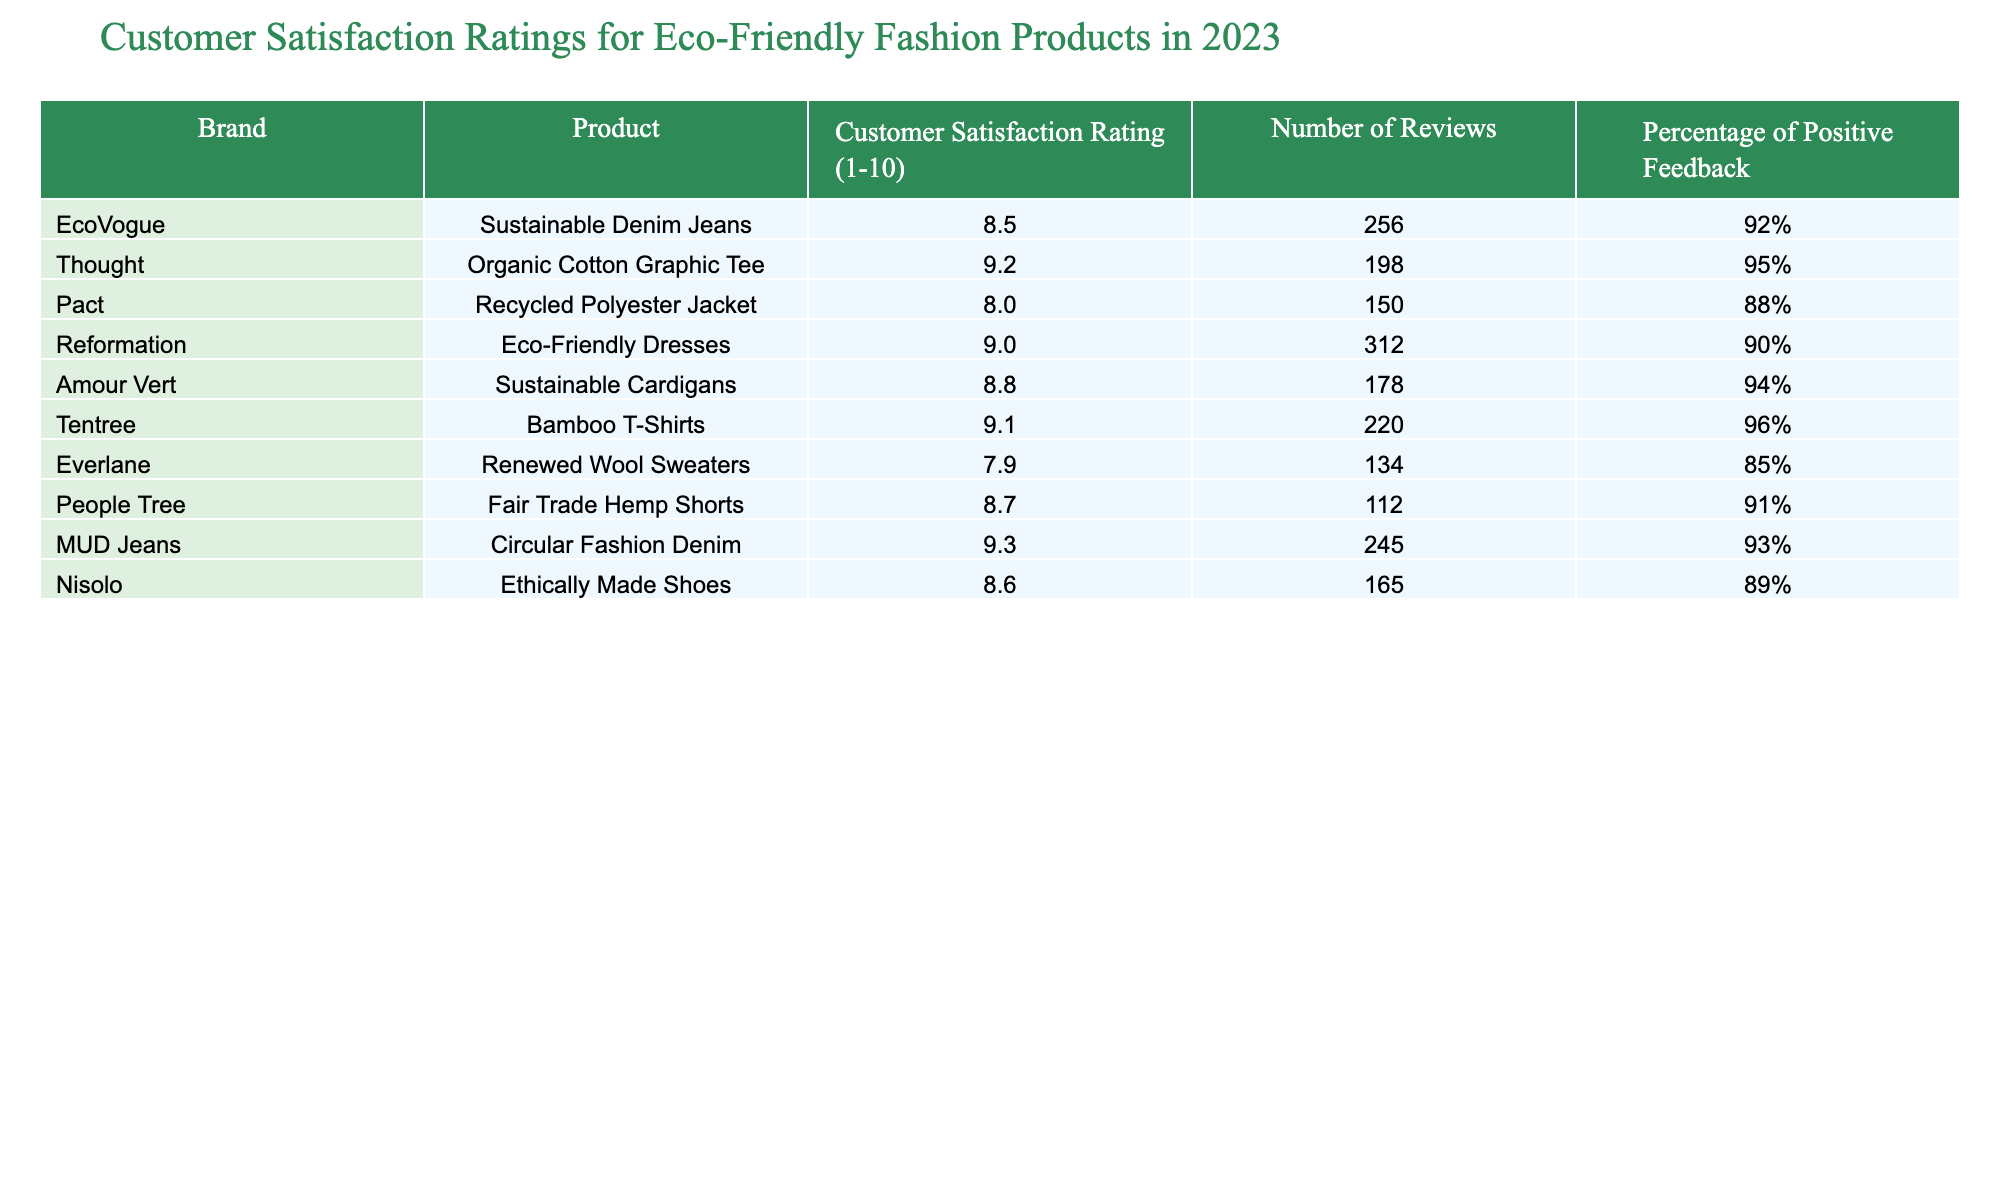What is the highest customer satisfaction rating for eco-friendly fashion products? The table lists various products and their satisfaction ratings. The highest rating observed is 9.3 for the MUD Jeans.
Answer: 9.3 Which eco-friendly fashion product has the lowest customer satisfaction rating? The table shows the satisfaction ratings for all products, and the lowest rating is 7.9 for the Everlane Renewed Wool Sweaters.
Answer: 7.9 How many reviews did the Thought Organic Cotton Graphic Tee receive? Referring to the table, the Thought product received 198 reviews.
Answer: 198 What is the percentage of positive feedback for Tentree Bamboo T-Shirts? The table indicates that the Tentree Bamboo T-Shirts have 96% positive feedback.
Answer: 96% Which brand has a product with a customer satisfaction rating of 9.0? Looking at the table, the Reformation Eco-Friendly Dresses have a customer satisfaction rating of 9.0.
Answer: Reformation What is the average customer satisfaction rating for products from Pact and Everlane? The satisfaction ratings are 8.0 for Pact and 7.9 for Everlane. To find the average, we add both ratings (8.0 + 7.9 = 15.9) and divide by 2, resulting in 15.9 / 2 = 7.95.
Answer: 7.95 How many total reviews did all the products listed in the table receive? First, we sum the number of reviews for each product: 256 + 198 + 150 + 312 + 178 + 220 + 134 + 112 + 245 + 165 = 1,825.
Answer: 1825 Is the percentage of positive feedback for EcoVogue's Sustainable Denim Jeans greater than 90%? The table shows that EcoVogue's product has 92% positive feedback, which is indeed greater than 90%.
Answer: Yes How does the customer satisfaction rating of Amour Vert's Sustainable Cardigans compare to that of Pact's Recycled Polyester Jacket? Amour Vert's rating is 8.8, while Pact's is 8.0; comparing both shows that 8.8 is greater than 8.0.
Answer: Amour Vert is higher What is the difference in the number of reviews between the product with the highest satisfaction rating and the product with the lowest? The highest rating (MUD Jeans) received 245 reviews, and the lowest (Everlane) received 134. The difference is calculated as 245 - 134 = 111.
Answer: 111 Which brand has a higher percentage of positive feedback: People Tree or Pact? People Tree has a positive feedback of 91%, while Pact has 88%. Comparing these percentages shows that People Tree is higher.
Answer: People Tree is higher 